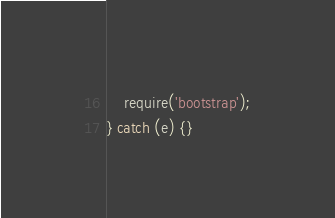<code> <loc_0><loc_0><loc_500><loc_500><_JavaScript_>
    require('bootstrap');
} catch (e) {}
</code> 